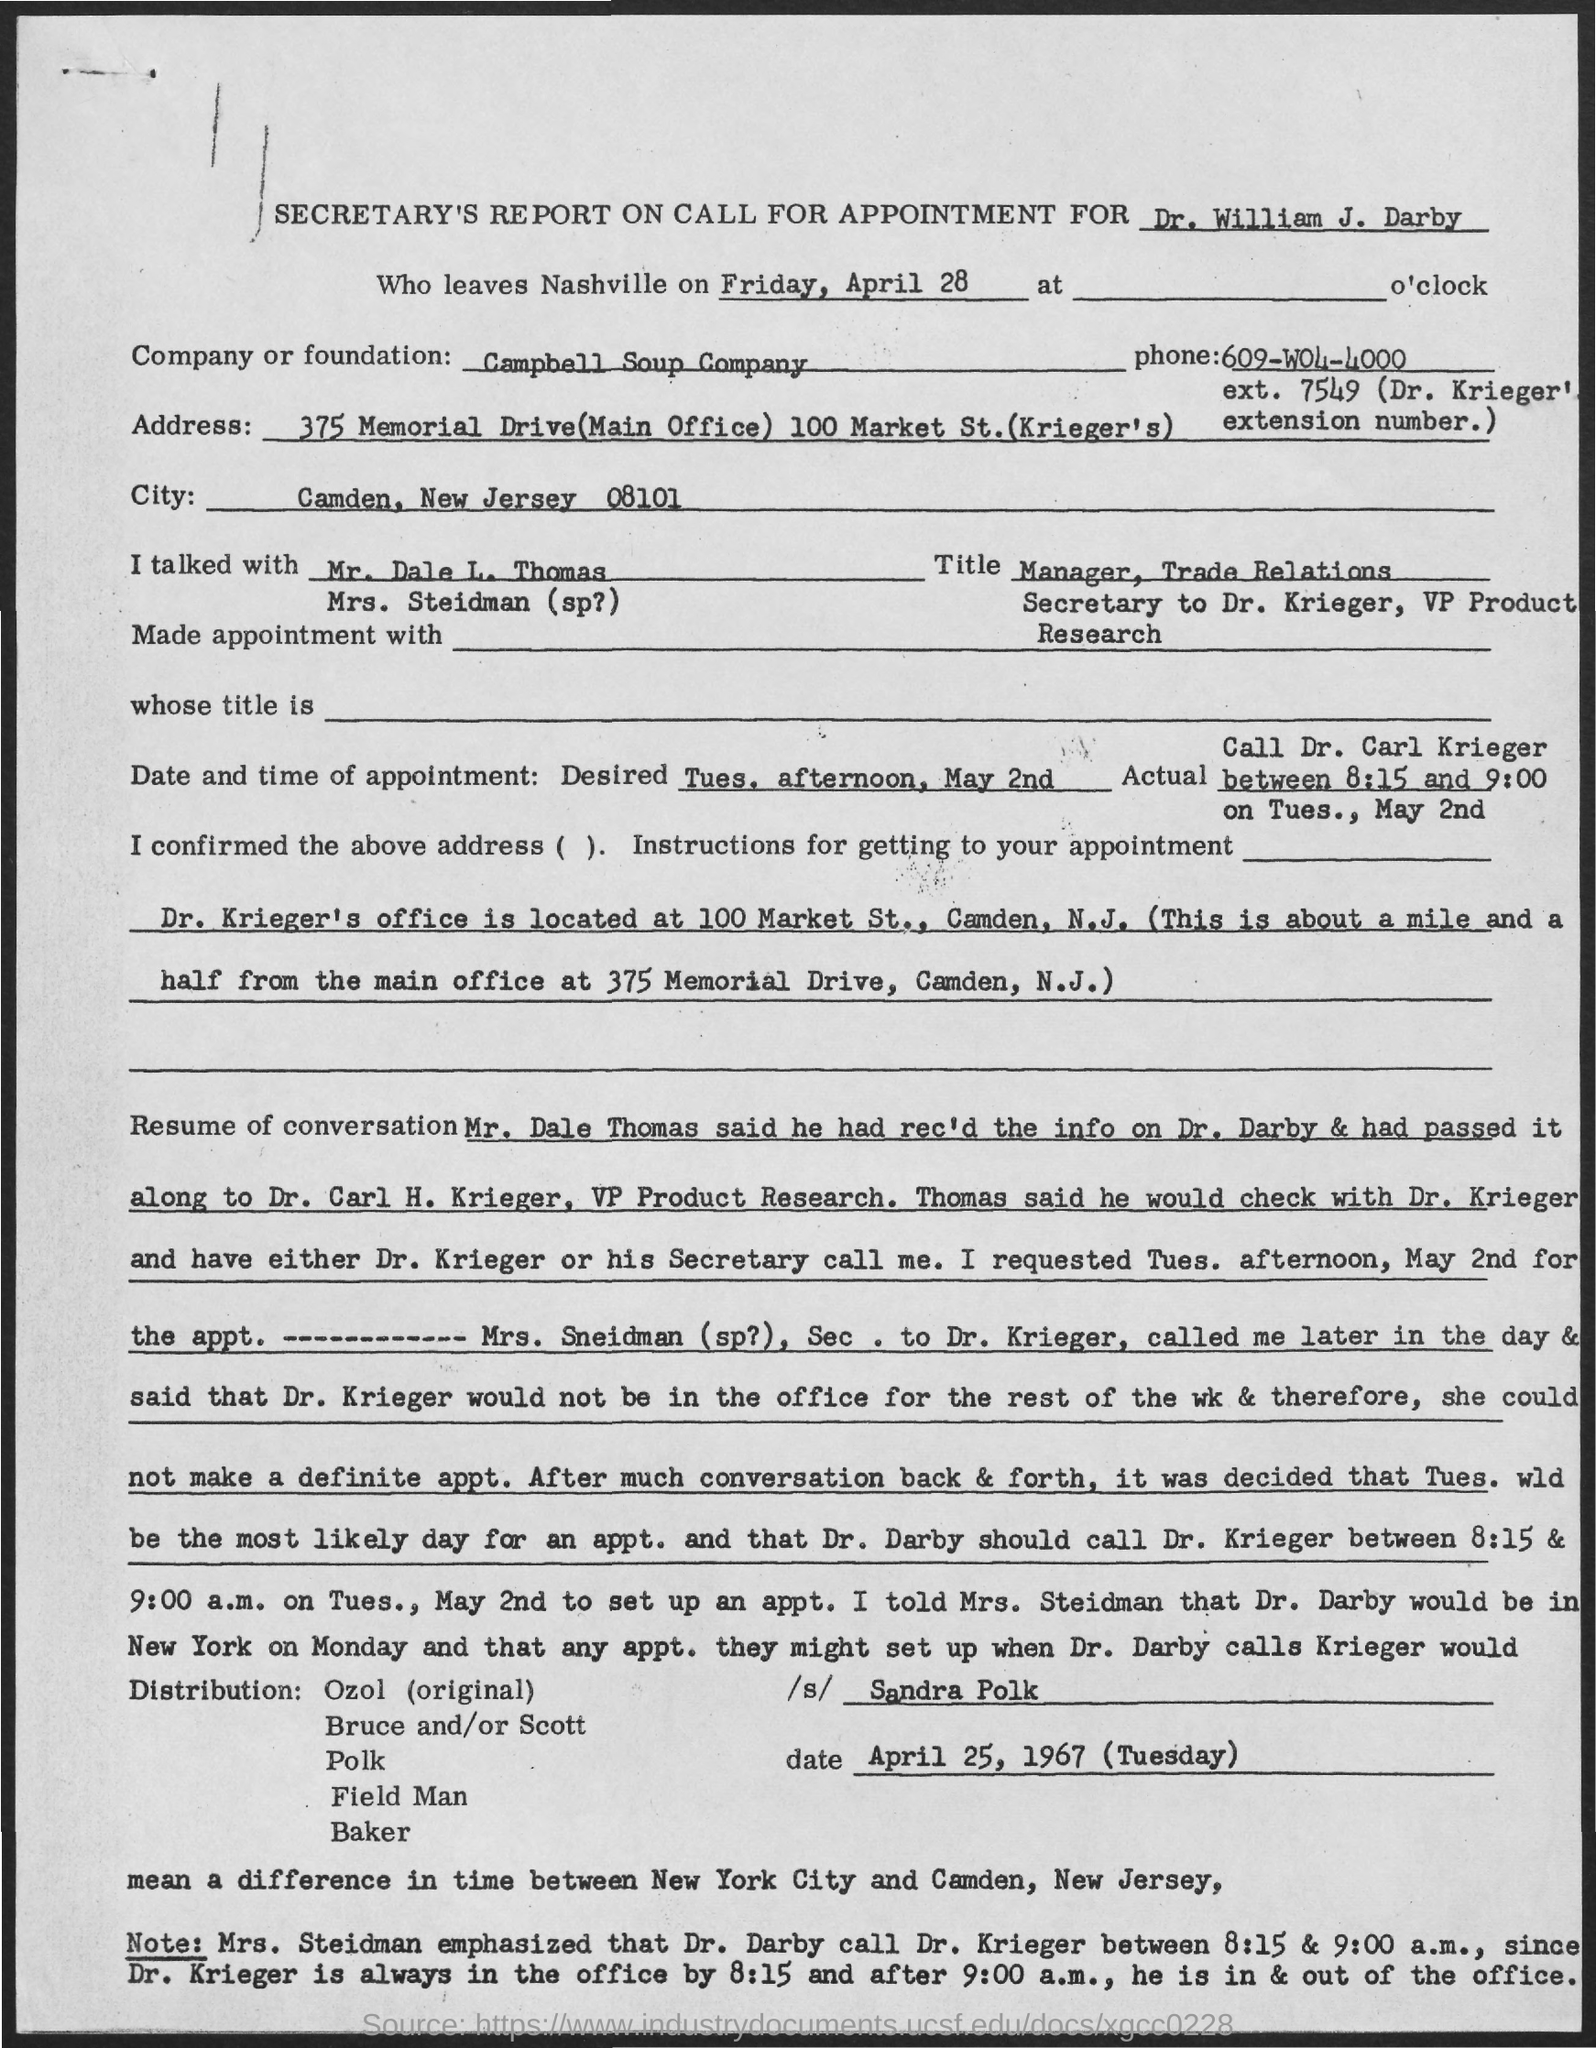What is the company mentioned in the document?
Provide a succinct answer. Campbell Soup Company. 